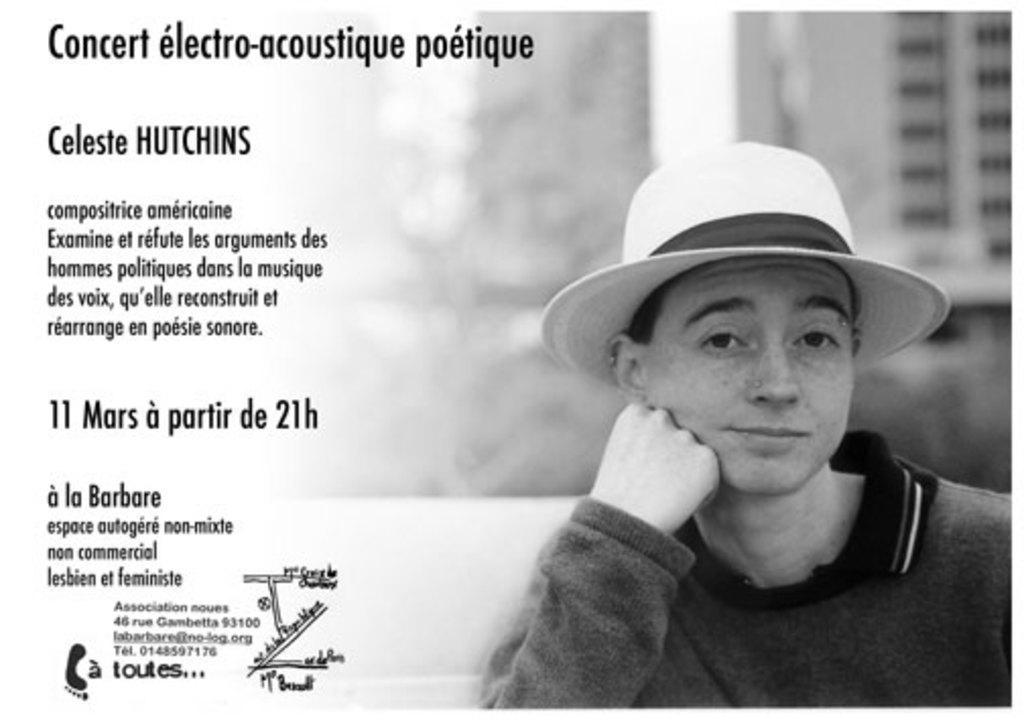Please provide a concise description of this image. This is an edited image. I can see a person with a hat. There is a blurred background. On the left side of the image, there are numbers, text and a logo. 